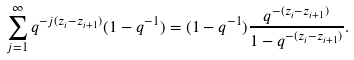<formula> <loc_0><loc_0><loc_500><loc_500>\sum _ { j = 1 } ^ { \infty } q ^ { - j ( z _ { i } - z _ { i + 1 } ) } ( 1 - q ^ { - 1 } ) = ( 1 - q ^ { - 1 } ) \frac { q ^ { - ( z _ { i } - z _ { i + 1 } ) } } { 1 - q ^ { - ( z _ { i } - z _ { i + 1 } ) } } .</formula> 